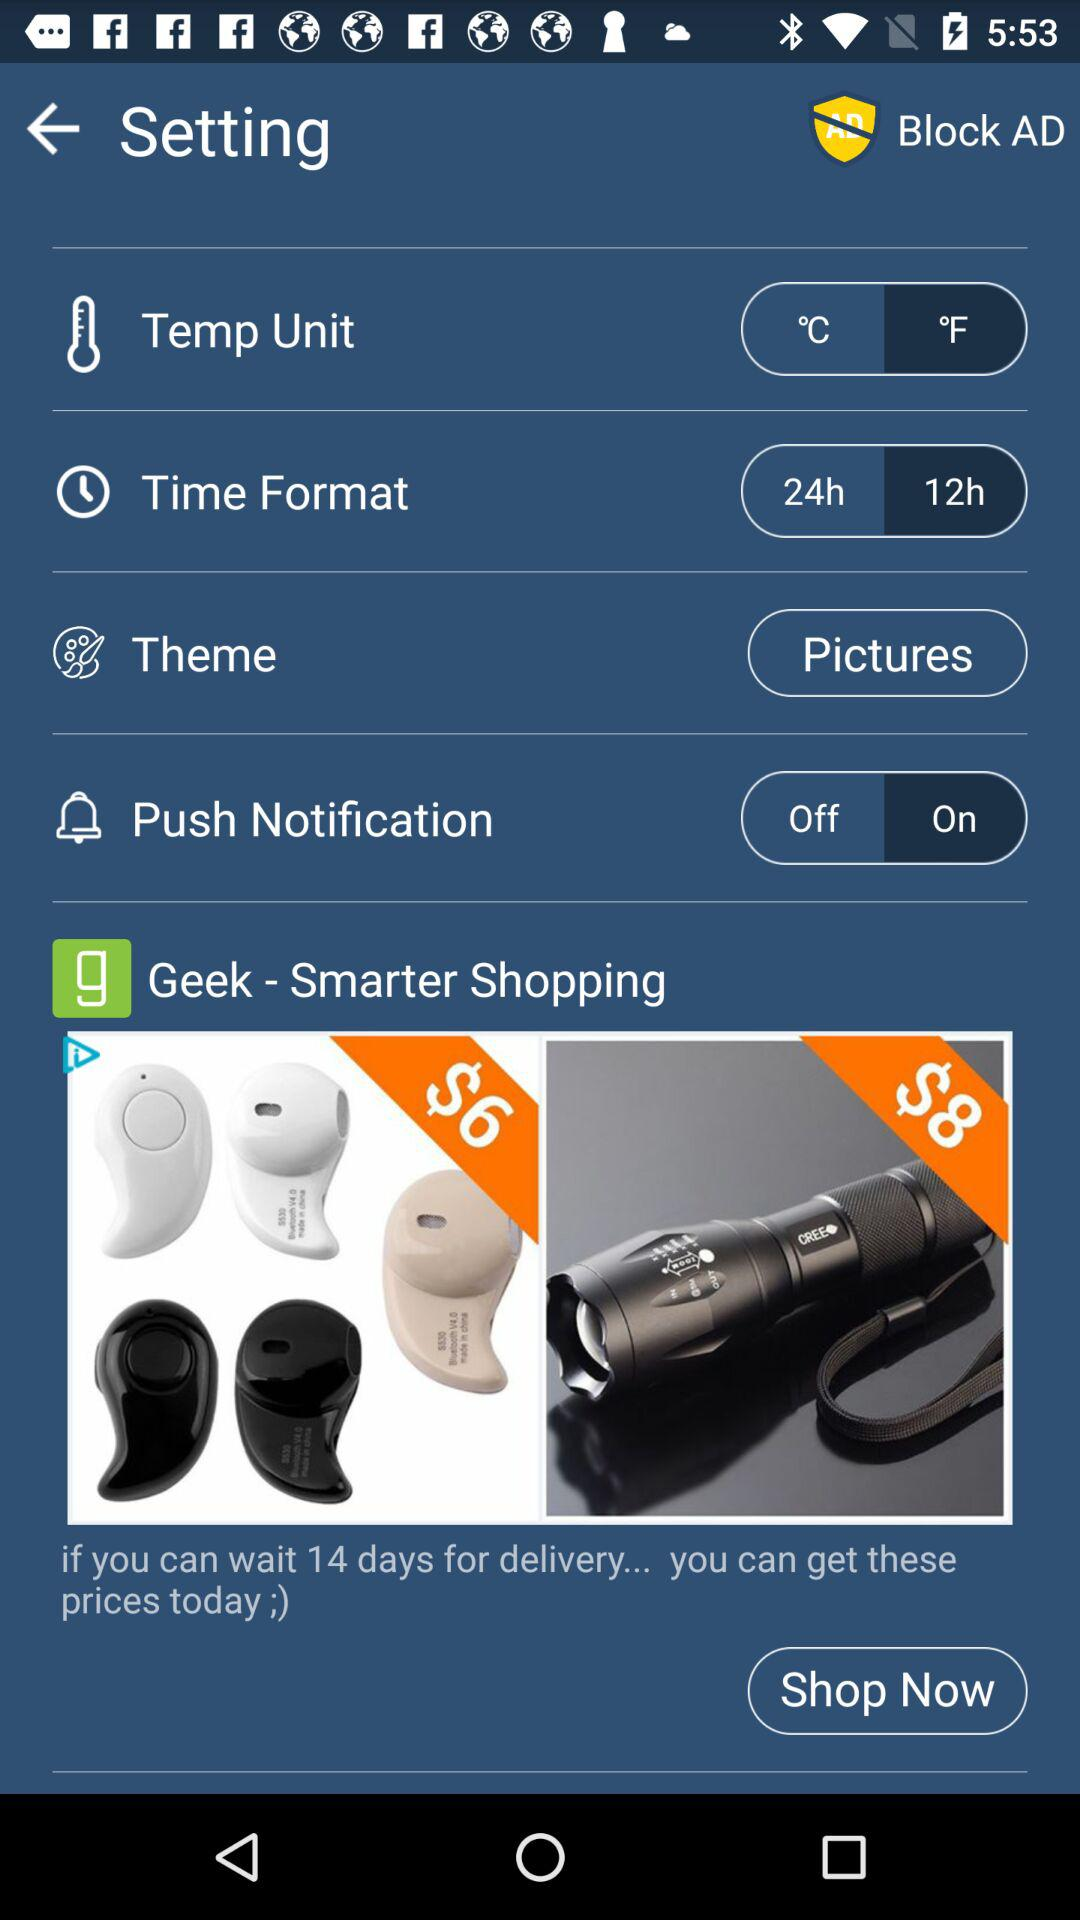What is the status of the "Push Notification"? The status of the "Push Notification" is "on". 